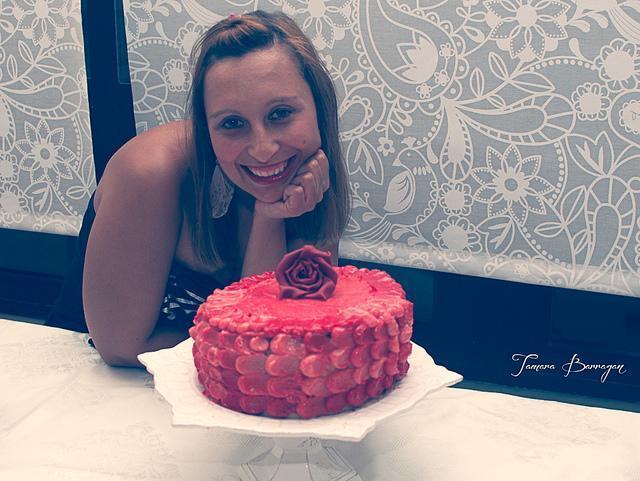How many green buses are on the road?
Give a very brief answer. 0. 